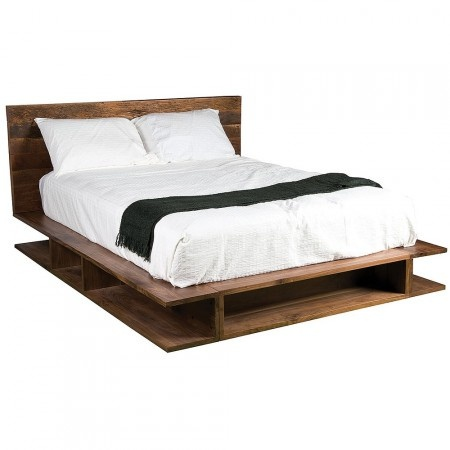Describe the objects in this image and their specific colors. I can see a bed in white, black, darkgray, and gray tones in this image. 